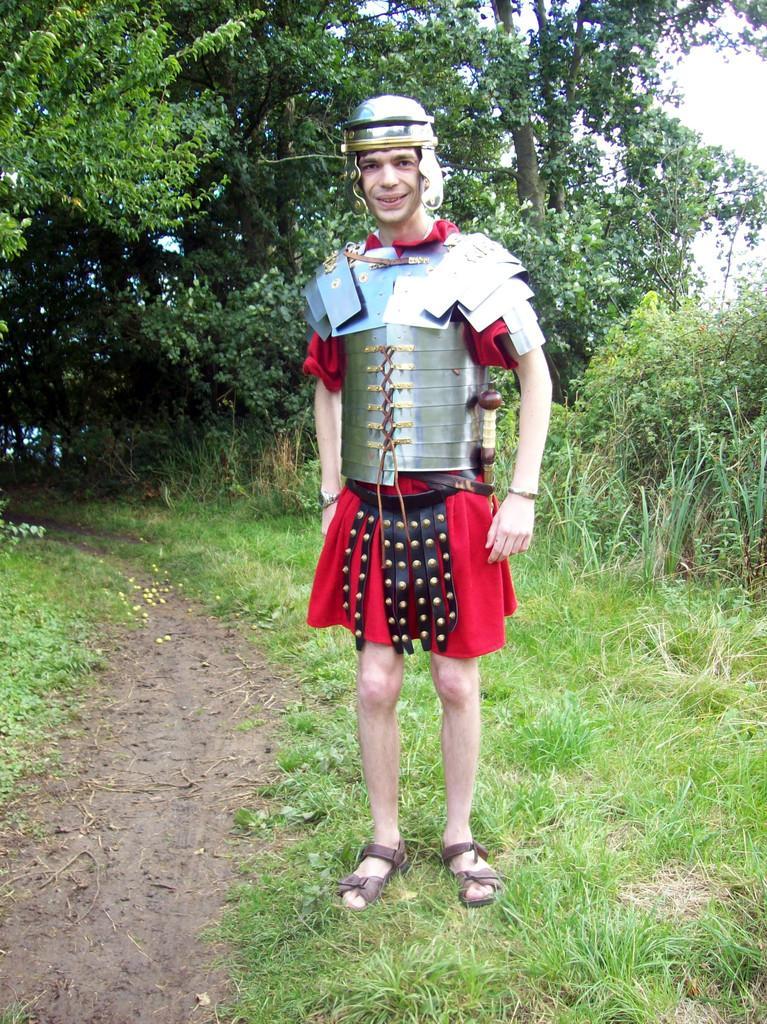Please provide a concise description of this image. In this image in the foreground I can see a man wearing warrior dress standing on the grass and at the back I can see many trees. 